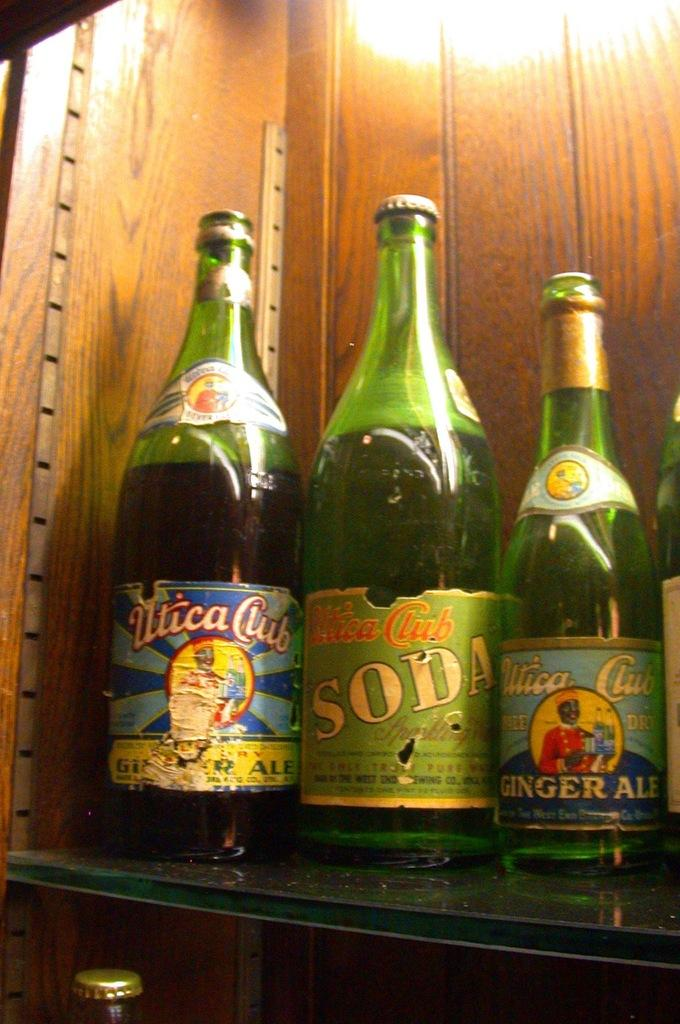What piece of furniture is present in the image? There is a table in the image. What objects are placed on the table? There are many bottles on the table. How many trees are visible in the image? There are no trees visible in the image; it only features a table with many bottles on it. 